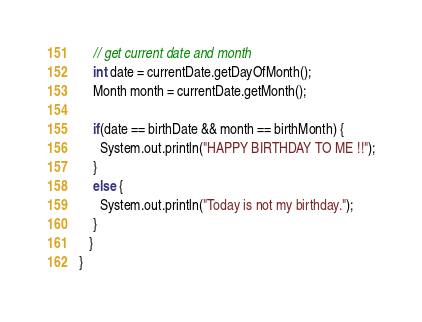Convert code to text. <code><loc_0><loc_0><loc_500><loc_500><_Java_>
    // get current date and month
    int date = currentDate.getDayOfMonth();
    Month month = currentDate.getMonth();

    if(date == birthDate && month == birthMonth) {
      System.out.println("HAPPY BIRTHDAY TO ME !!");
    }
    else {
      System.out.println("Today is not my birthday.");
    }
   }
}</code> 